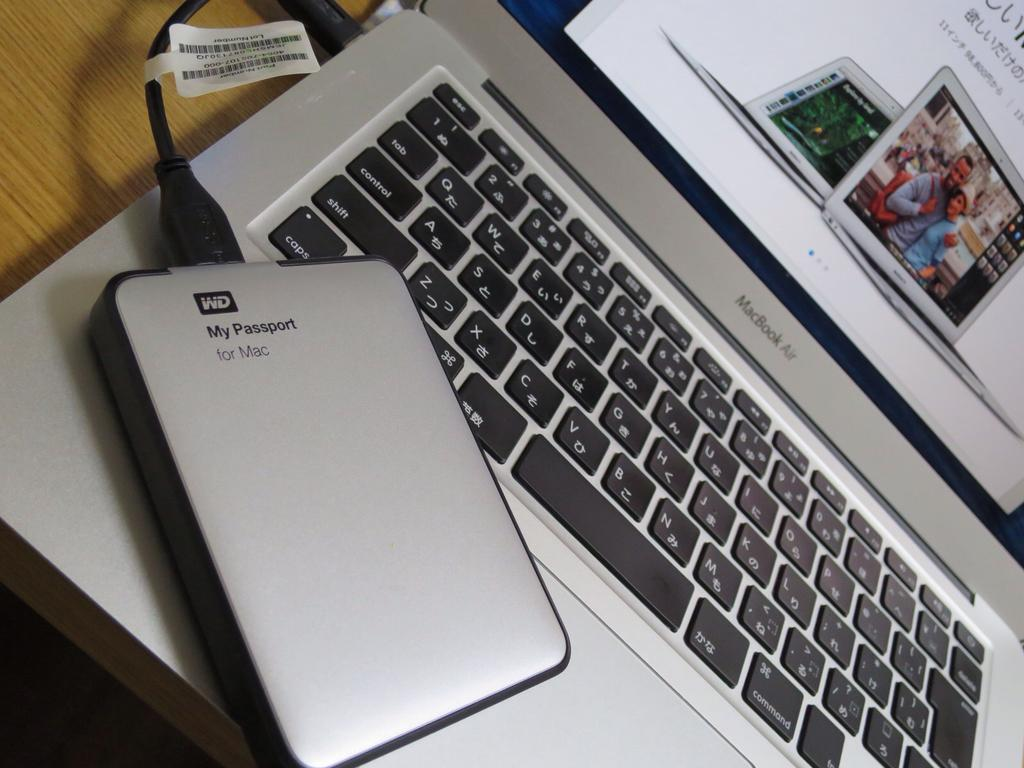<image>
Provide a brief description of the given image. A My Passport for Mac device is plugged into a MacBook Air. 